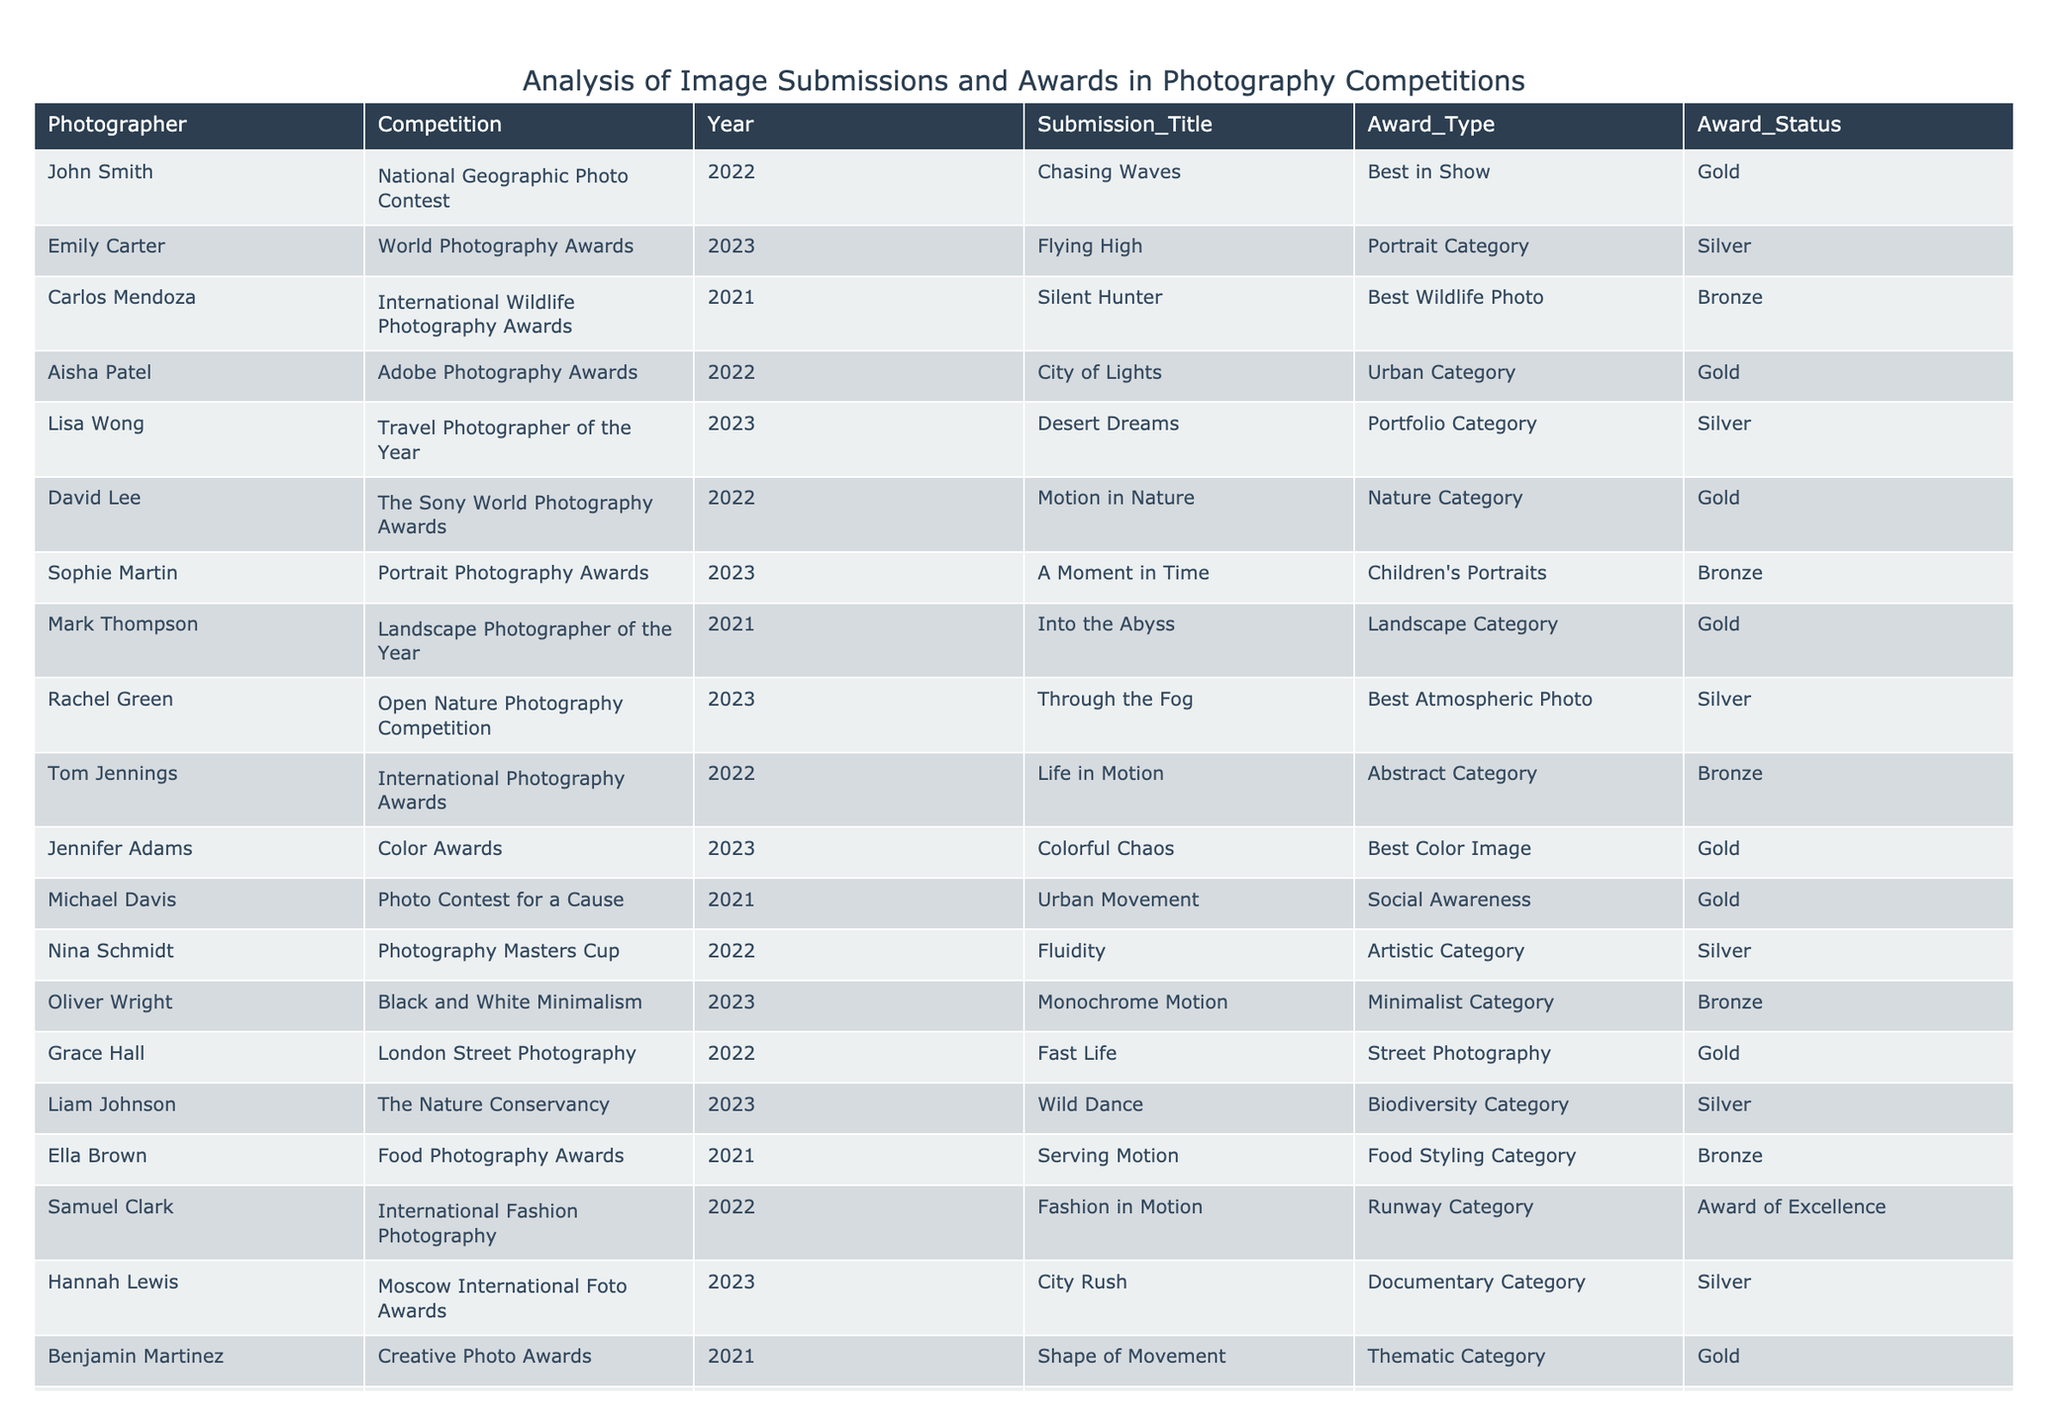What is the title of the submission by John Smith? The table lists John's submission title in the "Submission_Title" column, which is "Chasing Waves."
Answer: Chasing Waves How many awards did Aisha Patel win? Looking at Aisha Patel's entry, she won one award, which is a Gold award.
Answer: 1 Which competition did Jennifer Adams participate in? The table indicates that Jennifer Adams participated in the Color Awards competition.
Answer: Color Awards What award did Carlos Mendoza receive? Carlos Mendoza's entry states he received a Bronze award.
Answer: Bronze How many submissions won a Gold award? By counting the "Gold" entries in the "Award_Type" column, there are 6 Gold awards.
Answer: 6 Did Liam Johnson receive a Silver award? The data shows that Liam Johnson received a Silver award, confirming that the statement is true.
Answer: Yes Which photographer received awards in 2023? By scanning the Year column for 2023, the photographers are Emily Carter, Lisa Wong, Rachel Green, Oliver Wright, Liam Johnson, Hannah Lewis, and Jennifer Adams.
Answer: 7 Who won the award for "Best Atmospheric Photo"? Rachel Green is associated with the submission "Through the Fog," which won the award type "Best Atmospheric Photo."
Answer: Rachel Green What is the average number of awards won between the years 2021 and 2022? The total would be 4 (from 2021) + 5 (from 2022) = 9 submissions, with a total of 9 awards (2 Gold, 1 Silver, 1 Bronze from 2021; 3 Gold, 1 Silver, 1 Bronze from 2022). Therefore, the average is 9/9 = 1.
Answer: 1 Which photographer has the most recent win and what type was it? The most recent win is related to Emily Carter in 2023, who received a Silver award.
Answer: Emily Carter, Silver Was there any photographer who received an award but did not win first place? Yes, several photographers received Silver and Bronze awards, meaning they did not win first place.
Answer: Yes What is the total number of submissions by David Lee? David Lee submitted only one entry titled "Motion in Nature," indicating he has made one submission.
Answer: 1 Which award status is most common for submissions in 2022? There are 6 entries in 2022, with Gold being the most common award status (3 times), compared to Silver (2) and Bronze (1).
Answer: Gold How many photographers received Bronze awards? The table shows a total of 5 entries with Bronze awards listed next to different photographers.
Answer: 5 What was the title of the submission by Oliver Wright? Oliver Wright's submission title is "Monochrome Motion," as indicated in the table.
Answer: Monochrome Motion 